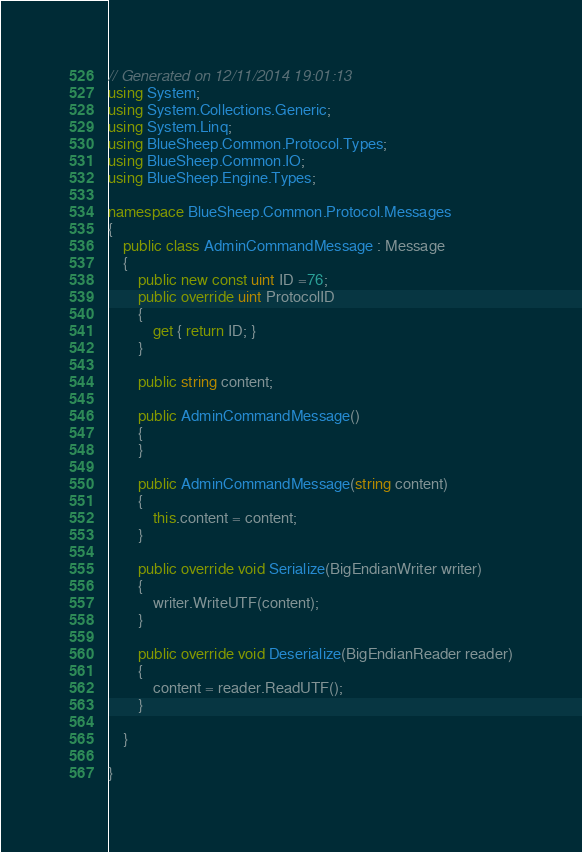Convert code to text. <code><loc_0><loc_0><loc_500><loc_500><_C#_>









// Generated on 12/11/2014 19:01:13
using System;
using System.Collections.Generic;
using System.Linq;
using BlueSheep.Common.Protocol.Types;
using BlueSheep.Common.IO;
using BlueSheep.Engine.Types;

namespace BlueSheep.Common.Protocol.Messages
{
    public class AdminCommandMessage : Message
    {
        public new const uint ID =76;
        public override uint ProtocolID
        {
            get { return ID; }
        }
        
        public string content;
        
        public AdminCommandMessage()
        {
        }
        
        public AdminCommandMessage(string content)
        {
            this.content = content;
        }
        
        public override void Serialize(BigEndianWriter writer)
        {
            writer.WriteUTF(content);
        }
        
        public override void Deserialize(BigEndianReader reader)
        {
            content = reader.ReadUTF();
        }
        
    }
    
}</code> 